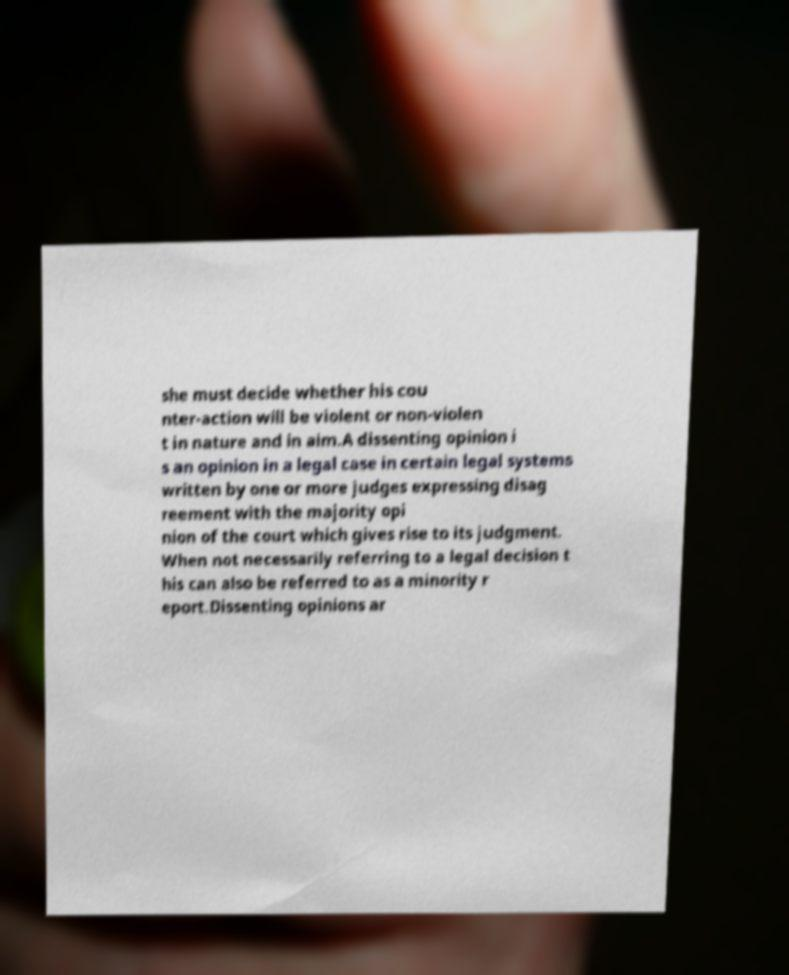What messages or text are displayed in this image? I need them in a readable, typed format. she must decide whether his cou nter-action will be violent or non-violen t in nature and in aim.A dissenting opinion i s an opinion in a legal case in certain legal systems written by one or more judges expressing disag reement with the majority opi nion of the court which gives rise to its judgment. When not necessarily referring to a legal decision t his can also be referred to as a minority r eport.Dissenting opinions ar 